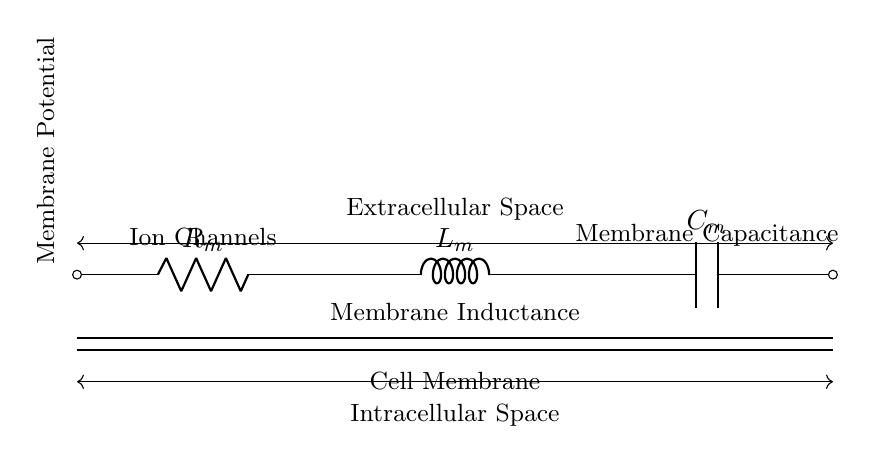What components are in this circuit? The circuit contains a resistor, an inductor, and a capacitor labeled R_m, L_m, and C_m, respectively.
Answer: Resistor, Inductor, Capacitor What does the subscript "m" signify in the component labels? The subscript "m" in R_m, L_m, and C_m denotes that these components are representative of the membrane properties, likely indicating that they simulate biological cell membrane characteristics.
Answer: Membrane properties What does the circuit simulate? This circuit simulates cell membrane potential changes by representing the dynamic interactions of resistive, inductive, and capacitive behaviors.
Answer: Cell membrane potential changes How are the components connected in the circuit? The components are connected in series: the resistor is first, followed by the inductor, and then the capacitor, which is located at the end of the circuit.
Answer: In series Why is there a distinction between extracellular and intracellular space in the diagram? The distinction stresses the physical environment of the cell membrane, with extracellular space representing the area outside the cell and intracellular space indicating the area within the cell, important for understanding membrane potential dynamics.
Answer: To highlight cellular environments What does the "Cell Membrane" label indicate? The label indicates the section of the circuit that corresponds to a biological cell membrane, emphasizing that the circuit models the behavior and properties of that membrane.
Answer: It corresponds to a biological cell membrane How does the presence of ion channels impact the circuit behavior? Ion channels affect the resistive properties of the membrane, allowing for selective ion flow, which can influence how the circuit responds to voltage changes, similar to how real cells generate action potentials.
Answer: They influence resistive properties 